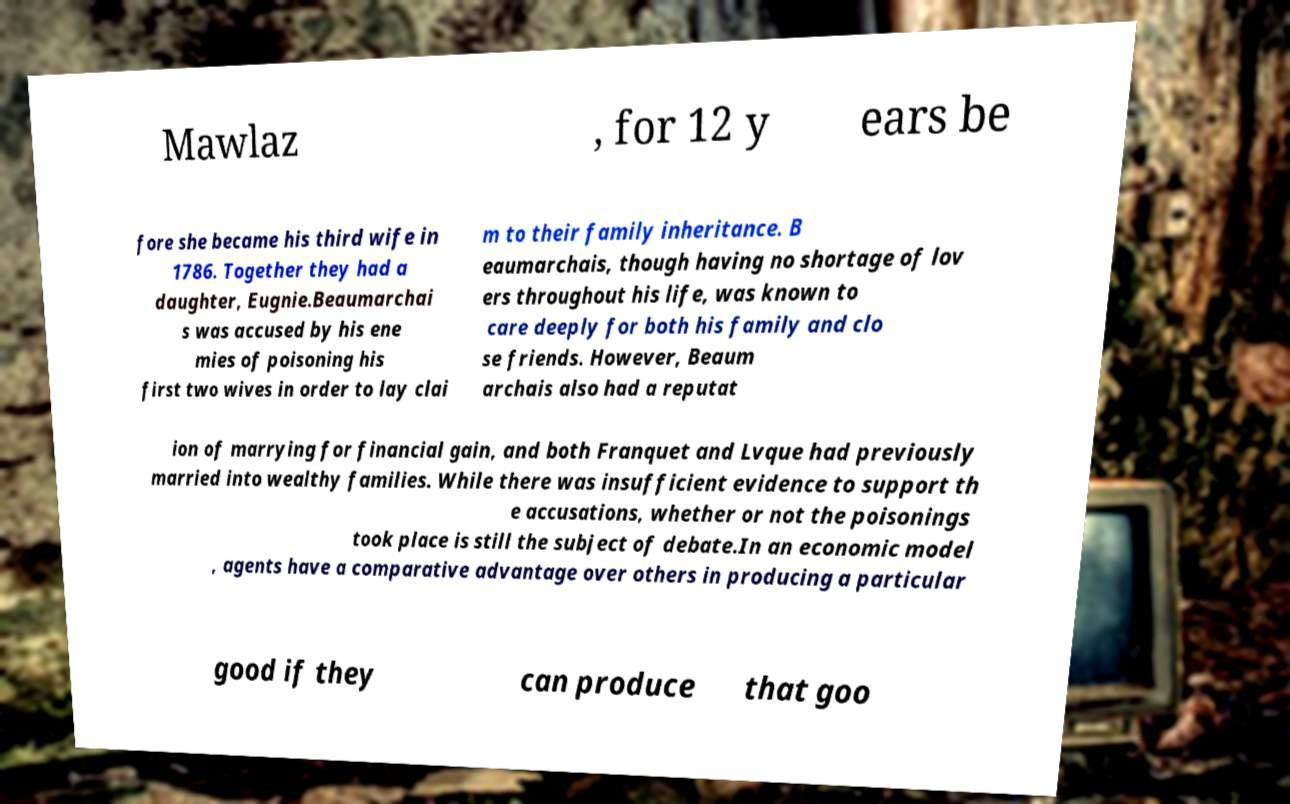Please read and relay the text visible in this image. What does it say? Mawlaz , for 12 y ears be fore she became his third wife in 1786. Together they had a daughter, Eugnie.Beaumarchai s was accused by his ene mies of poisoning his first two wives in order to lay clai m to their family inheritance. B eaumarchais, though having no shortage of lov ers throughout his life, was known to care deeply for both his family and clo se friends. However, Beaum archais also had a reputat ion of marrying for financial gain, and both Franquet and Lvque had previously married into wealthy families. While there was insufficient evidence to support th e accusations, whether or not the poisonings took place is still the subject of debate.In an economic model , agents have a comparative advantage over others in producing a particular good if they can produce that goo 